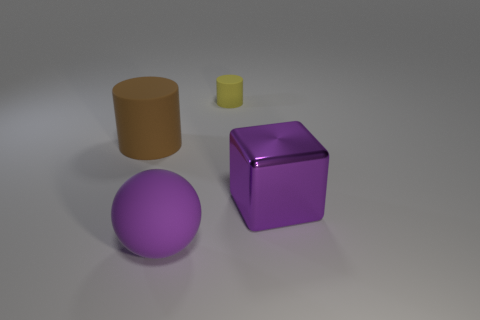Add 3 small cyan things. How many objects exist? 7 Subtract all brown cylinders. How many cylinders are left? 1 Subtract 0 gray cylinders. How many objects are left? 4 Subtract all blocks. How many objects are left? 3 Subtract 1 cylinders. How many cylinders are left? 1 Subtract all red cylinders. Subtract all purple spheres. How many cylinders are left? 2 Subtract all red cubes. How many brown cylinders are left? 1 Subtract all tiny yellow things. Subtract all large purple blocks. How many objects are left? 2 Add 2 small matte cylinders. How many small matte cylinders are left? 3 Add 3 cyan cubes. How many cyan cubes exist? 3 